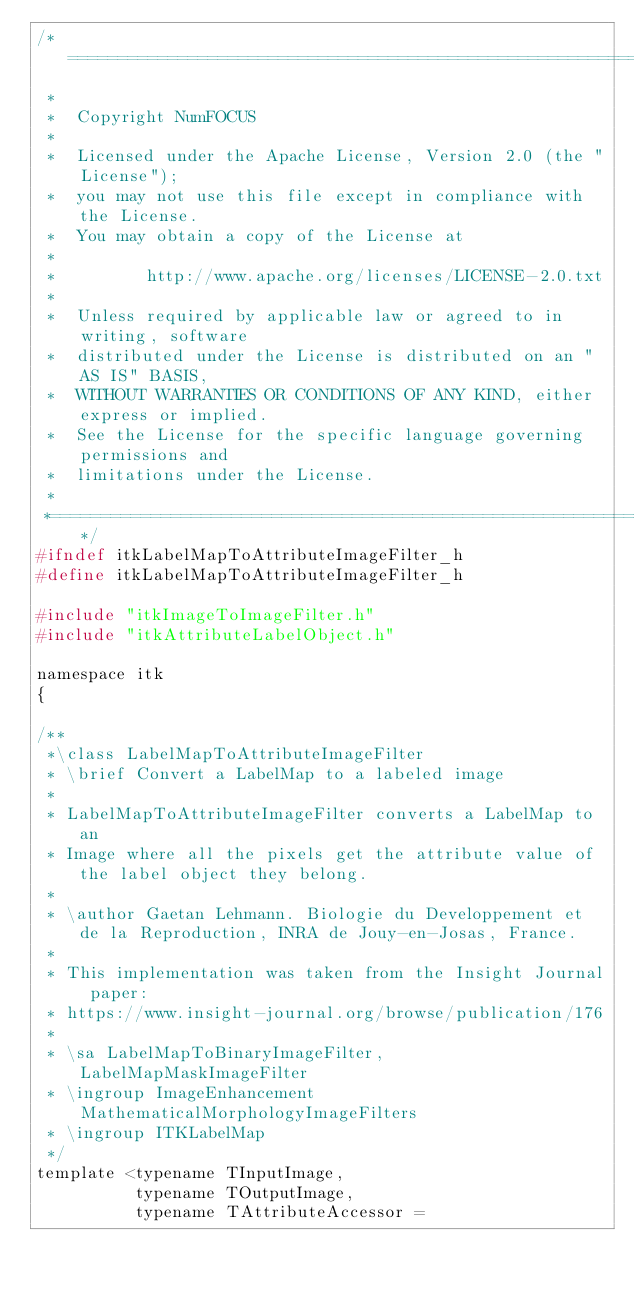Convert code to text. <code><loc_0><loc_0><loc_500><loc_500><_C_>/*=========================================================================
 *
 *  Copyright NumFOCUS
 *
 *  Licensed under the Apache License, Version 2.0 (the "License");
 *  you may not use this file except in compliance with the License.
 *  You may obtain a copy of the License at
 *
 *         http://www.apache.org/licenses/LICENSE-2.0.txt
 *
 *  Unless required by applicable law or agreed to in writing, software
 *  distributed under the License is distributed on an "AS IS" BASIS,
 *  WITHOUT WARRANTIES OR CONDITIONS OF ANY KIND, either express or implied.
 *  See the License for the specific language governing permissions and
 *  limitations under the License.
 *
 *=========================================================================*/
#ifndef itkLabelMapToAttributeImageFilter_h
#define itkLabelMapToAttributeImageFilter_h

#include "itkImageToImageFilter.h"
#include "itkAttributeLabelObject.h"

namespace itk
{

/**
 *\class LabelMapToAttributeImageFilter
 * \brief Convert a LabelMap to a labeled image
 *
 * LabelMapToAttributeImageFilter converts a LabelMap to an
 * Image where all the pixels get the attribute value of the label object they belong.
 *
 * \author Gaetan Lehmann. Biologie du Developpement et de la Reproduction, INRA de Jouy-en-Josas, France.
 *
 * This implementation was taken from the Insight Journal paper:
 * https://www.insight-journal.org/browse/publication/176
 *
 * \sa LabelMapToBinaryImageFilter, LabelMapMaskImageFilter
 * \ingroup ImageEnhancement  MathematicalMorphologyImageFilters
 * \ingroup ITKLabelMap
 */
template <typename TInputImage,
          typename TOutputImage,
          typename TAttributeAccessor =</code> 